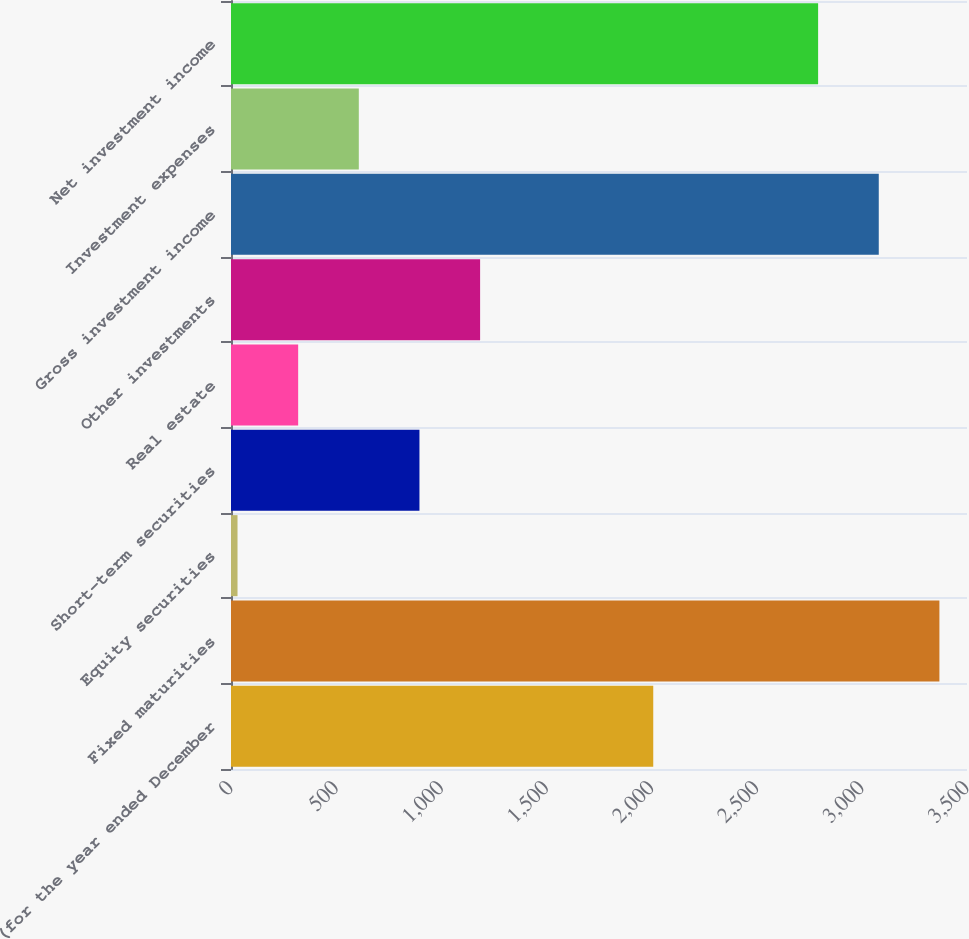<chart> <loc_0><loc_0><loc_500><loc_500><bar_chart><fcel>(for the year ended December<fcel>Fixed maturities<fcel>Equity securities<fcel>Short-term securities<fcel>Real estate<fcel>Other investments<fcel>Gross investment income<fcel>Investment expenses<fcel>Net investment income<nl><fcel>2008<fcel>3368.8<fcel>31<fcel>896.2<fcel>319.4<fcel>1184.6<fcel>3080.4<fcel>607.8<fcel>2792<nl></chart> 